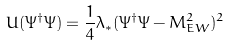<formula> <loc_0><loc_0><loc_500><loc_500>U ( \Psi ^ { \dag } \Psi ) = \frac { 1 } { 4 } \lambda _ { * } ( \Psi ^ { \dag } \Psi - M _ { E W } ^ { 2 } ) ^ { 2 }</formula> 